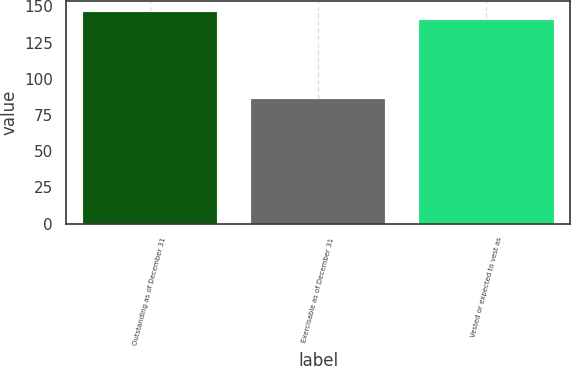<chart> <loc_0><loc_0><loc_500><loc_500><bar_chart><fcel>Outstanding as of December 31<fcel>Exercisable as of December 31<fcel>Vested or expected to vest as<nl><fcel>146.28<fcel>85.85<fcel>140.78<nl></chart> 